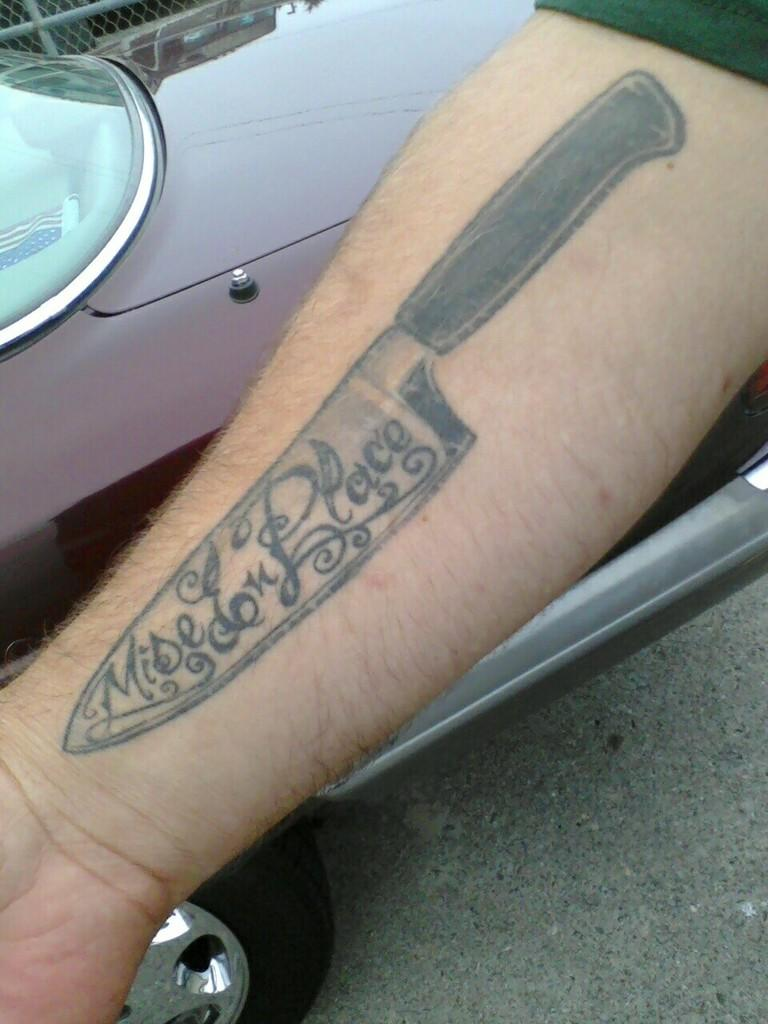What can be seen on the person's hand in the image? There is a tattoo on the person's hand in the image. What does the tattoo depict? The tattoo depicts a knife and some text. What is visible in the background of the image? There is a vehicle on the ground in the background of the image. What type of wine is being poured from the bottle in the image? There is no wine or bottle present in the image; it features a person's hand with a tattoo and a vehicle in the background. What body part is the tattoo located on in the image? The tattoo is located on the person's hand in the image. 